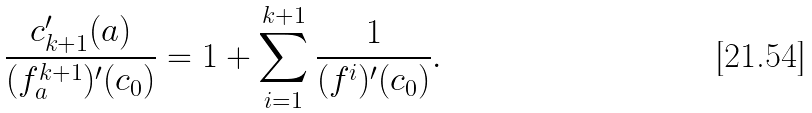Convert formula to latex. <formula><loc_0><loc_0><loc_500><loc_500>\frac { c _ { k + 1 } ^ { \prime } ( a ) } { ( f ^ { k + 1 } _ { a } ) ^ { \prime } ( c _ { 0 } ) } = 1 + \sum _ { i = 1 } ^ { k + 1 } \frac { 1 } { ( f ^ { i } ) ^ { \prime } ( c _ { 0 } ) } .</formula> 